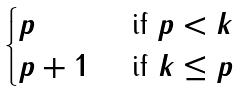Convert formula to latex. <formula><loc_0><loc_0><loc_500><loc_500>\begin{cases} p & \text { if } p < k \\ p + 1 & \text { if } k \leq p \end{cases}</formula> 